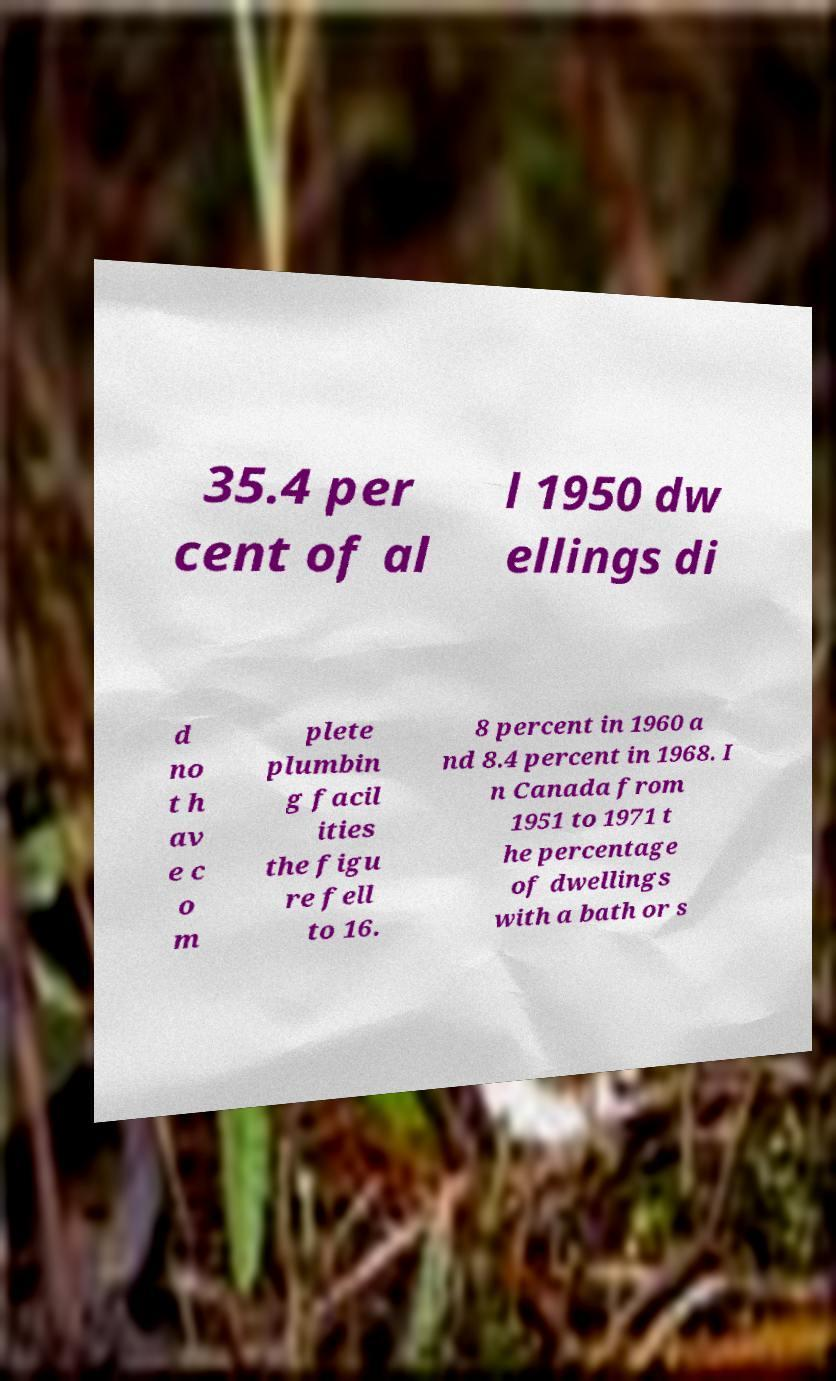What messages or text are displayed in this image? I need them in a readable, typed format. 35.4 per cent of al l 1950 dw ellings di d no t h av e c o m plete plumbin g facil ities the figu re fell to 16. 8 percent in 1960 a nd 8.4 percent in 1968. I n Canada from 1951 to 1971 t he percentage of dwellings with a bath or s 